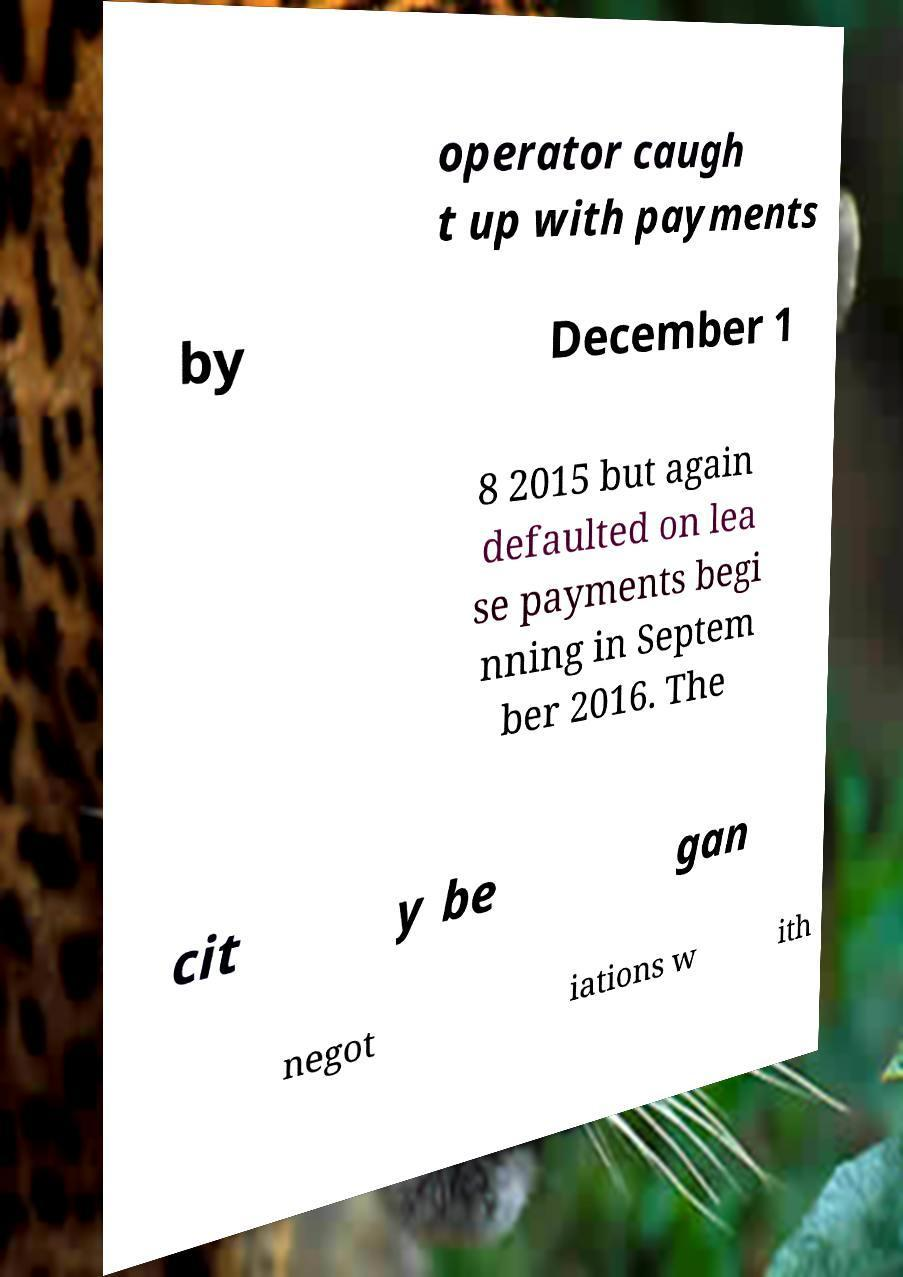Can you accurately transcribe the text from the provided image for me? operator caugh t up with payments by December 1 8 2015 but again defaulted on lea se payments begi nning in Septem ber 2016. The cit y be gan negot iations w ith 